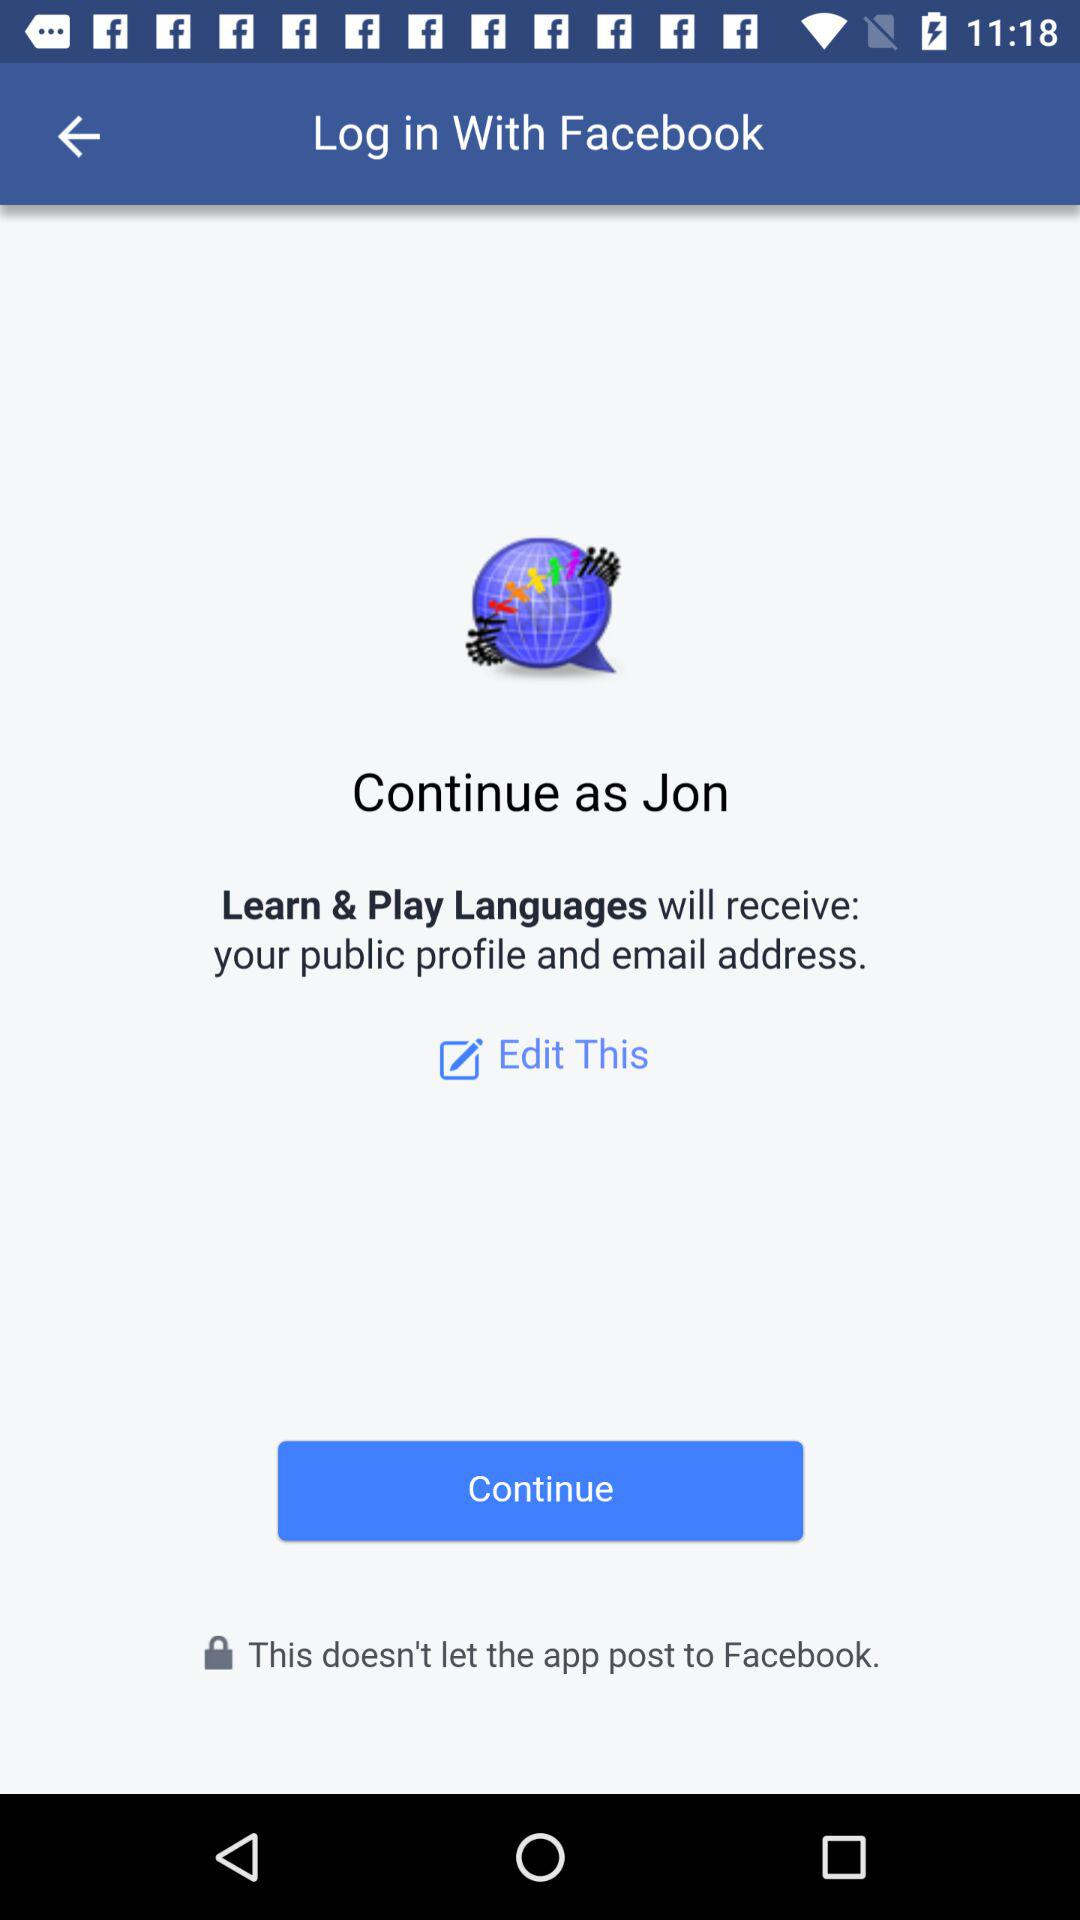Through what application can we log in? You can login with Facebook. 